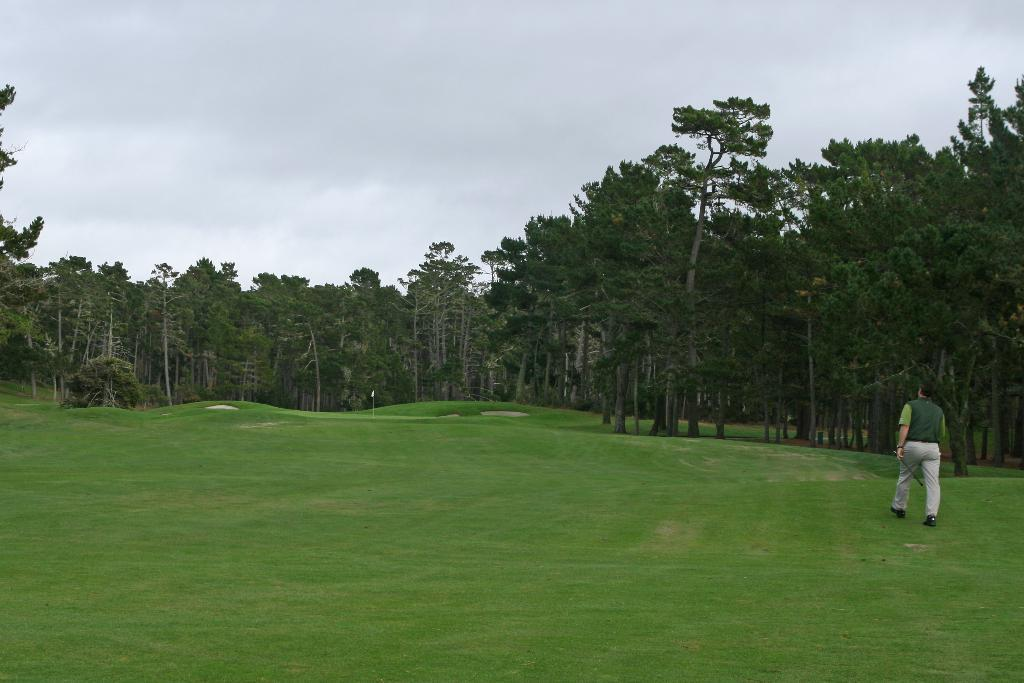What type of vegetation is present in the image? There is grass in the image. What is the person wearing in the image? The person is wearing a green jacket in the image. Which direction is the person walking in the image? The person is walking on the right side in the image. What else can be seen in the image besides the grass and person? There are trees in the image. What is visible at the top of the image? The sky is visible at the top of the image. What type of hat is the person wearing in the image? There is no hat visible in the image; the person is wearing a green jacket. How is the glue being used in the image? There is no glue present in the image. 